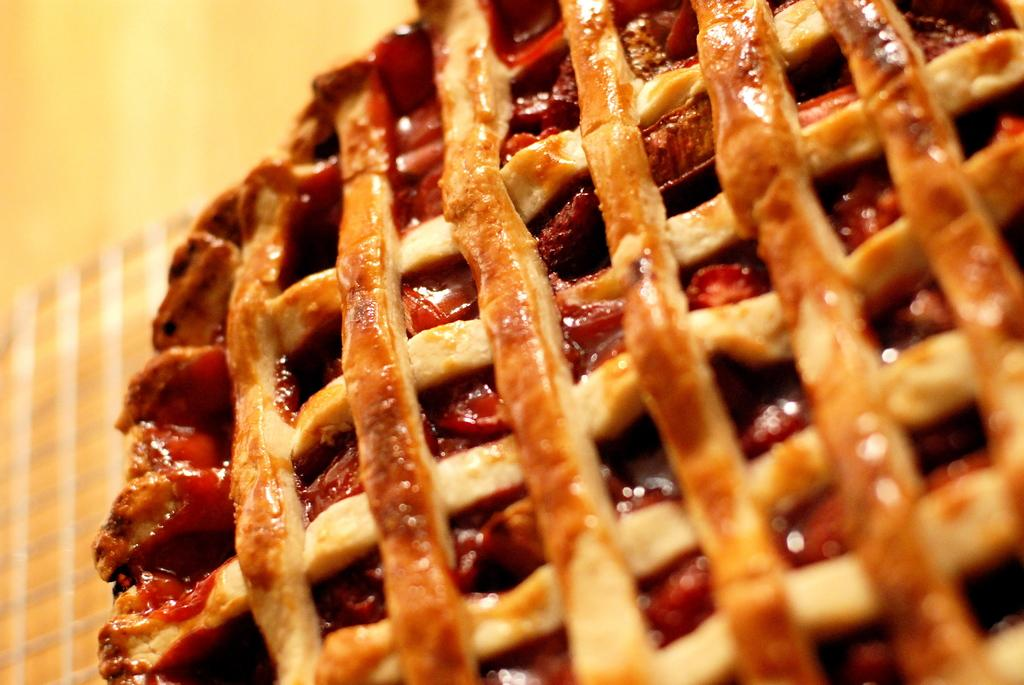What type of food is visible in the image? The food in the image has brown and cream colors. Can you describe the background of the image? The background of the image is cream colored. What letter is being held by the thumb in the image? There is no thumb or letter present in the image. 